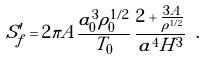<formula> <loc_0><loc_0><loc_500><loc_500>S _ { f } ^ { \prime } = 2 \pi A \frac { a _ { 0 } ^ { 3 } \rho _ { 0 } ^ { 1 / 2 } } { T _ { 0 } } \, \frac { 2 + \frac { 3 A } { \rho ^ { 1 / 2 } } } { a ^ { 4 } H ^ { 3 } } \ .</formula> 